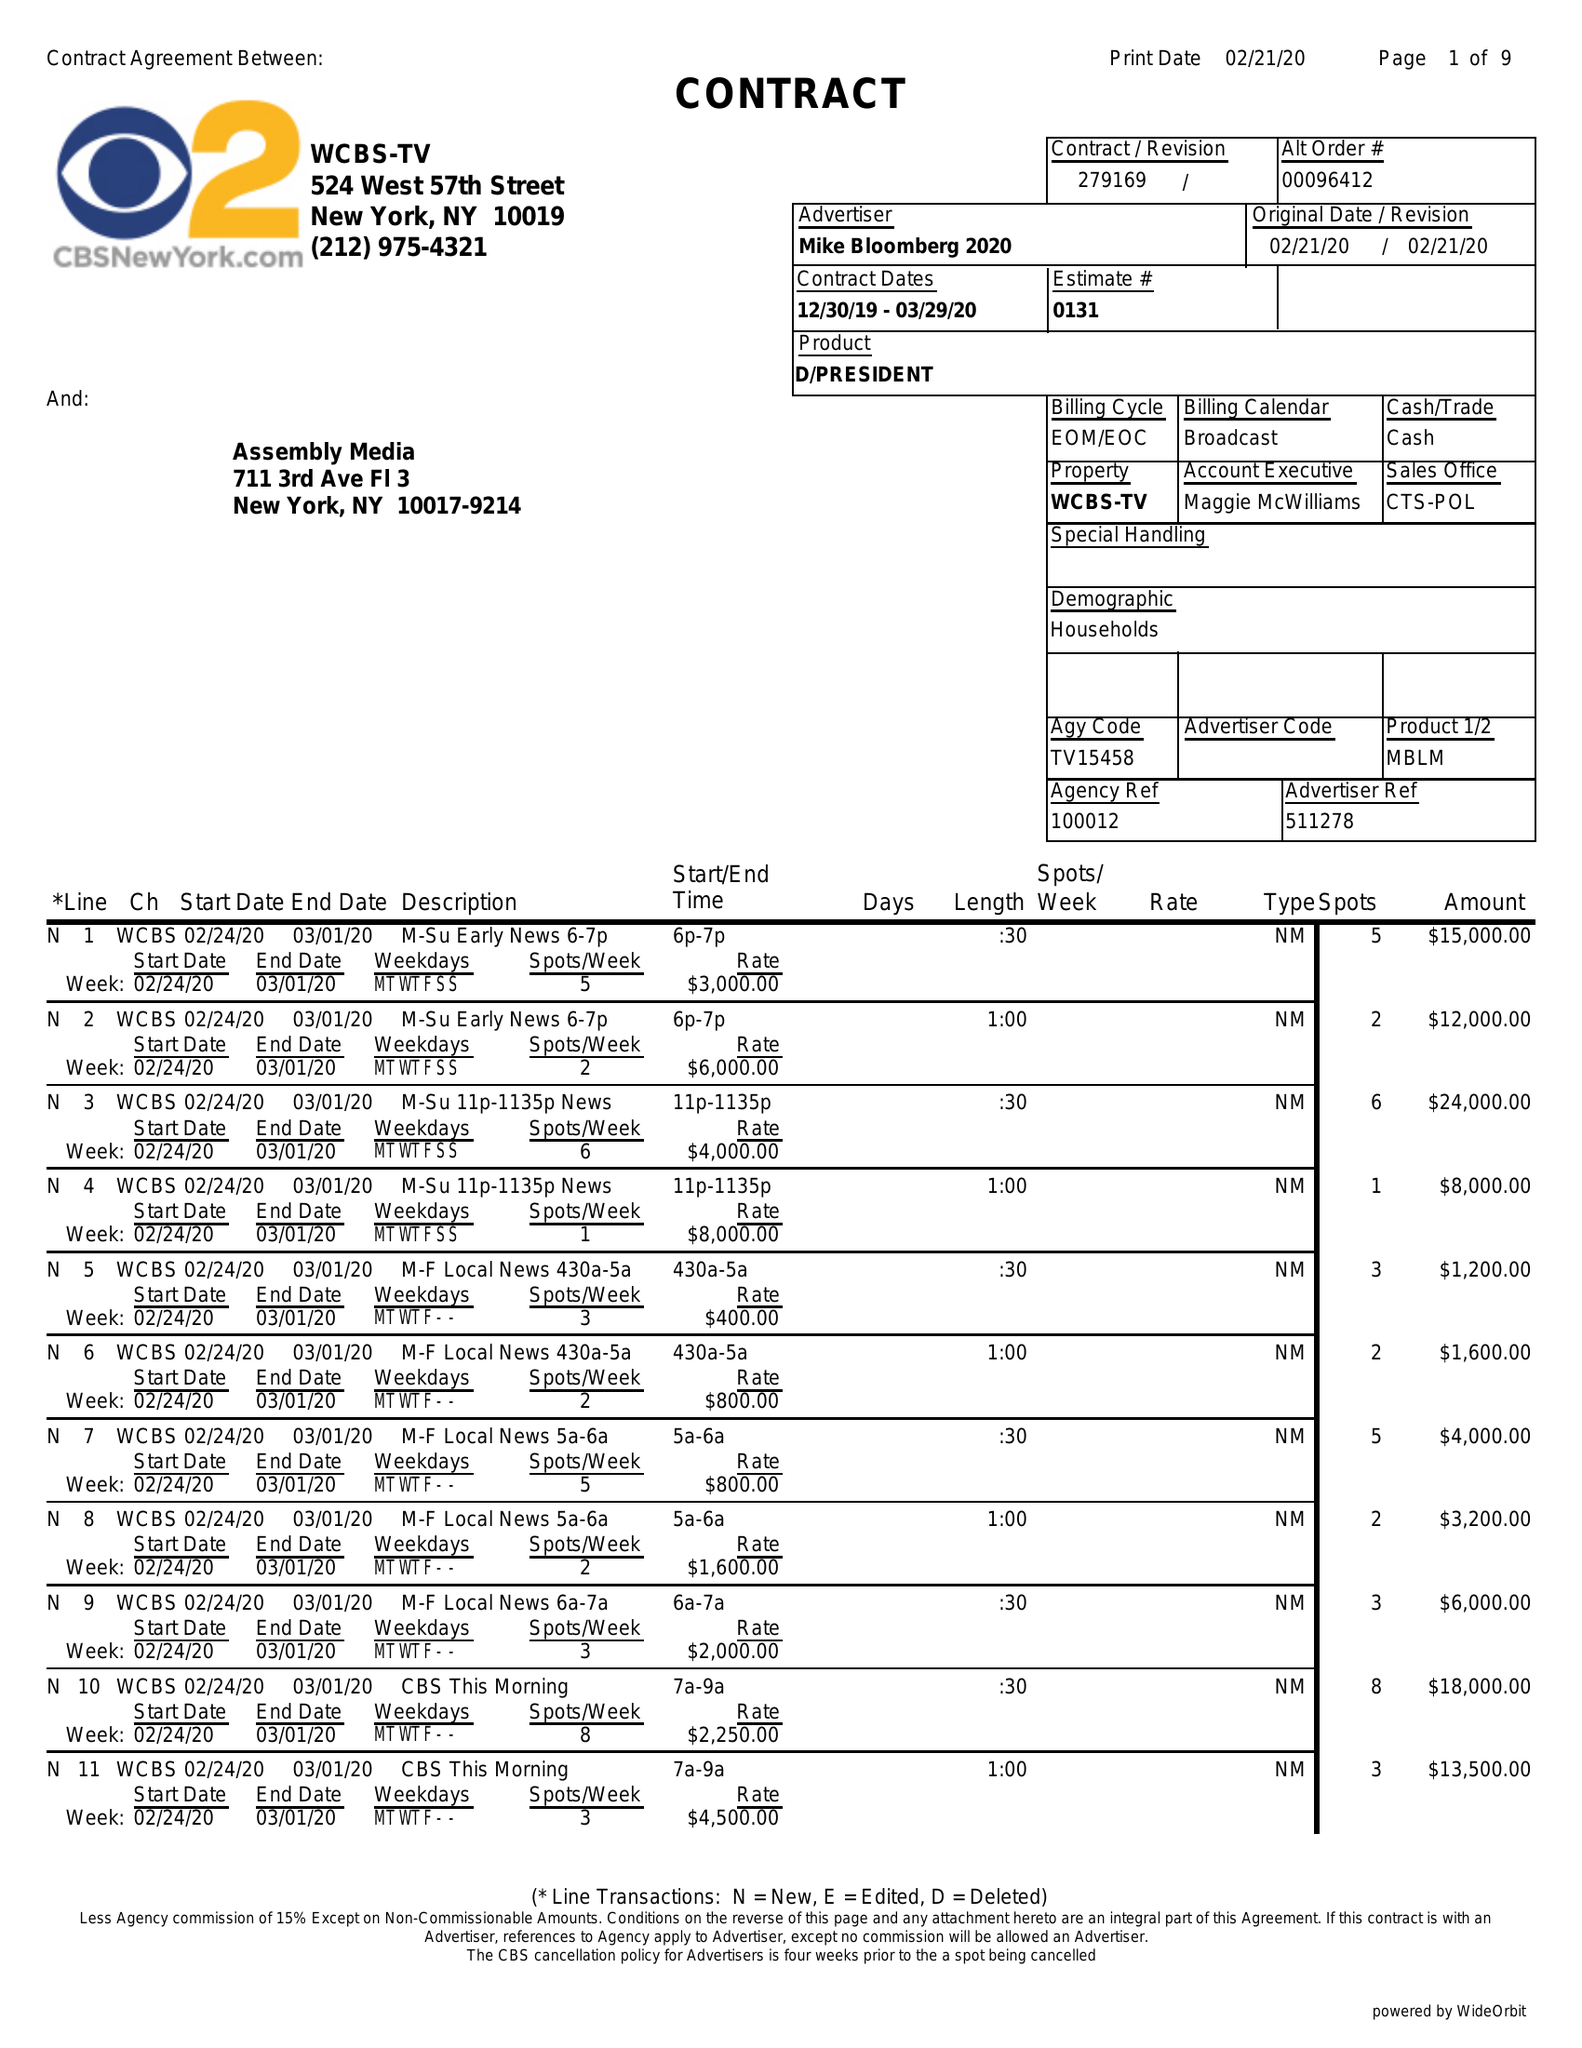What is the value for the flight_to?
Answer the question using a single word or phrase. 03/29/20 